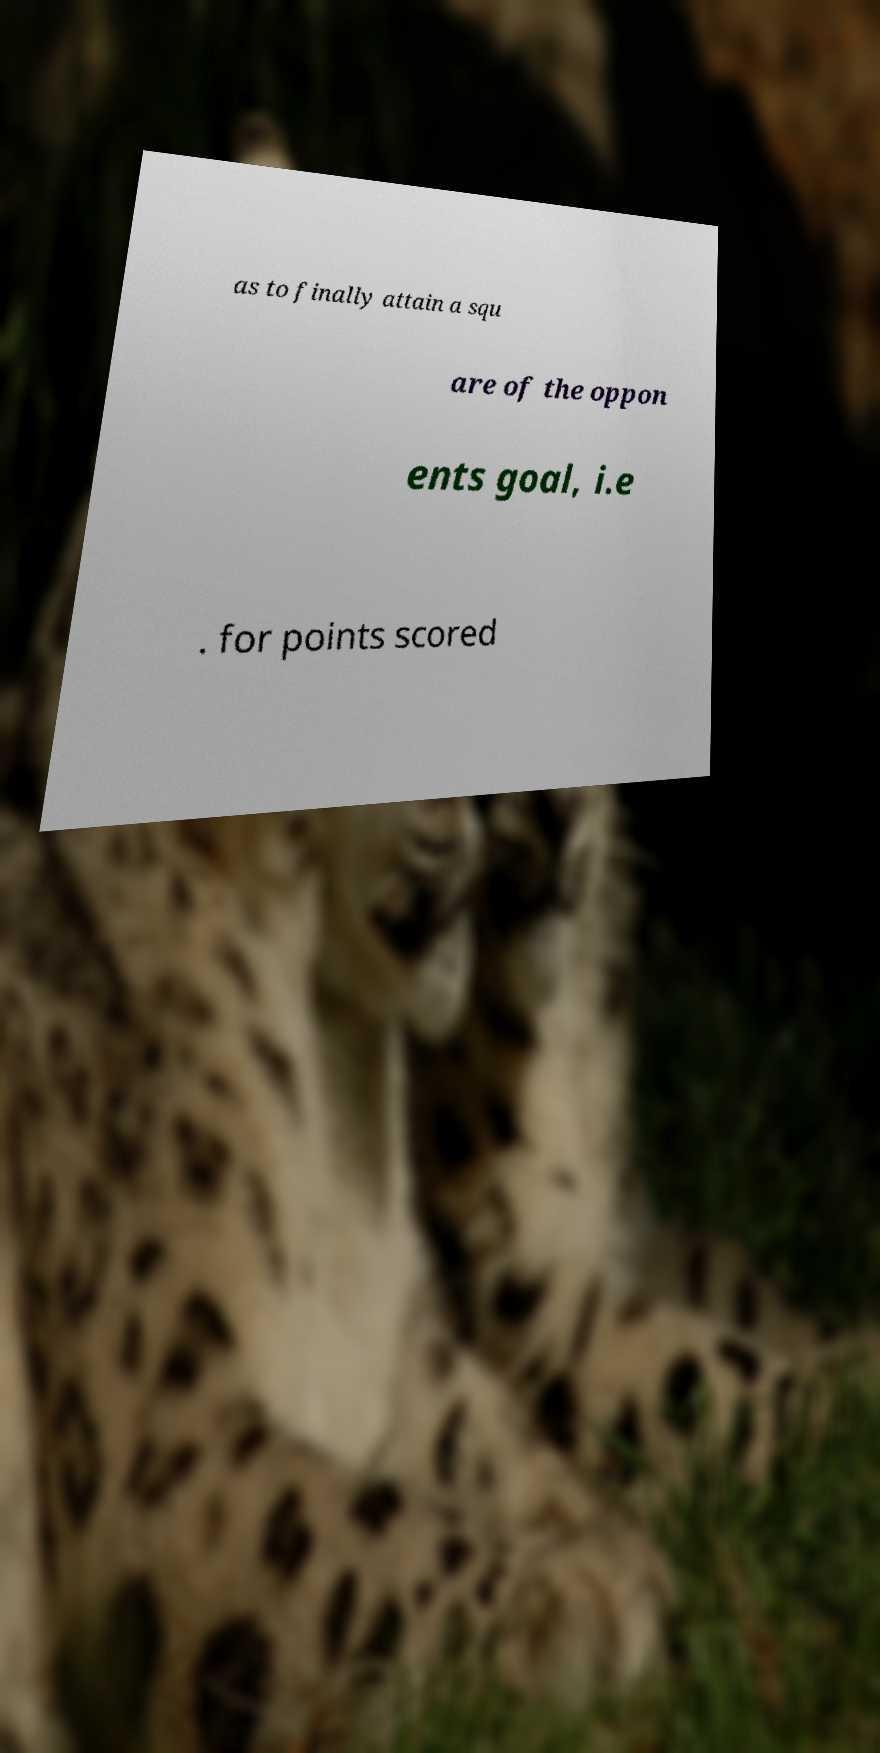Please read and relay the text visible in this image. What does it say? as to finally attain a squ are of the oppon ents goal, i.e . for points scored 